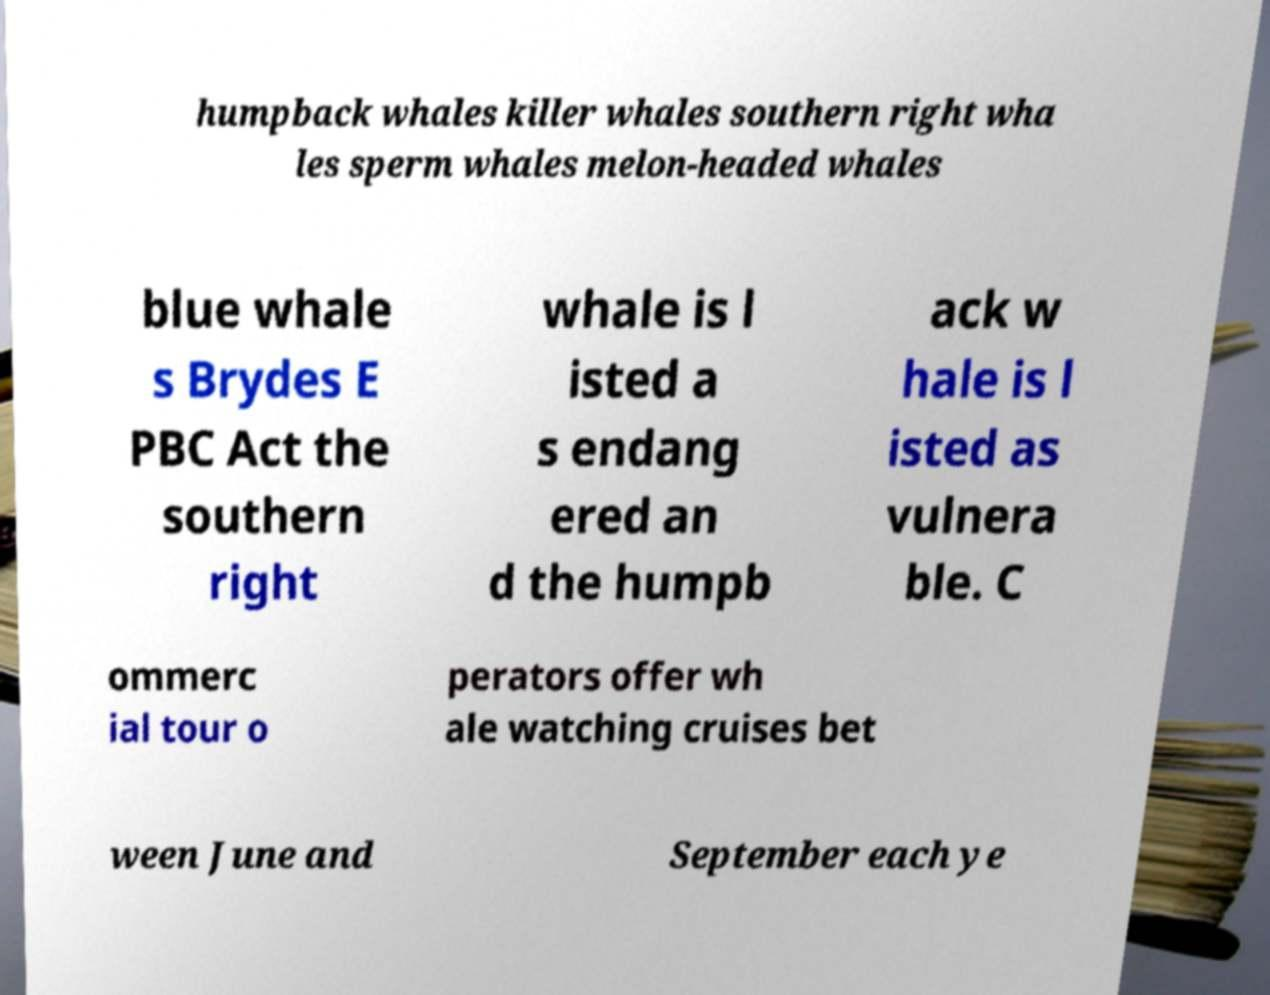I need the written content from this picture converted into text. Can you do that? humpback whales killer whales southern right wha les sperm whales melon-headed whales blue whale s Brydes E PBC Act the southern right whale is l isted a s endang ered an d the humpb ack w hale is l isted as vulnera ble. C ommerc ial tour o perators offer wh ale watching cruises bet ween June and September each ye 